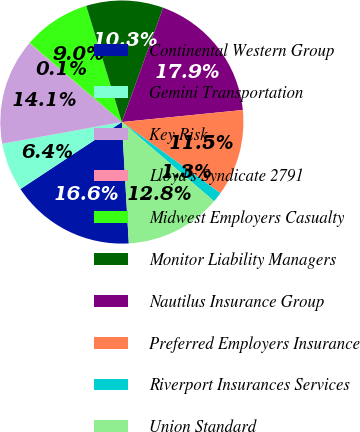<chart> <loc_0><loc_0><loc_500><loc_500><pie_chart><fcel>Continental Western Group<fcel>Gemini Transportation<fcel>Key Risk<fcel>Lloyd's Syndicate 2791<fcel>Midwest Employers Casualty<fcel>Monitor Liability Managers<fcel>Nautilus Insurance Group<fcel>Preferred Employers Insurance<fcel>Riverport Insurances Services<fcel>Union Standard<nl><fcel>16.62%<fcel>6.43%<fcel>14.08%<fcel>0.06%<fcel>8.98%<fcel>10.25%<fcel>17.9%<fcel>11.53%<fcel>1.34%<fcel>12.8%<nl></chart> 